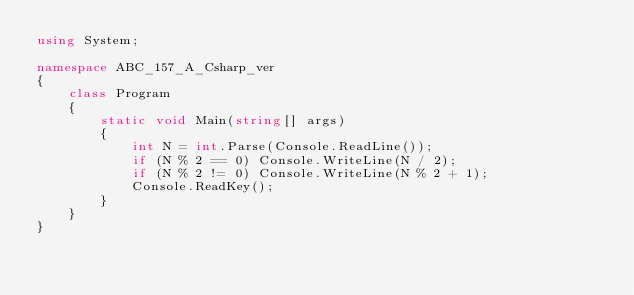Convert code to text. <code><loc_0><loc_0><loc_500><loc_500><_C#_>using System;

namespace ABC_157_A_Csharp_ver
{
    class Program
    {
        static void Main(string[] args)
        {
            int N = int.Parse(Console.ReadLine());
            if (N % 2 == 0) Console.WriteLine(N / 2);
            if (N % 2 != 0) Console.WriteLine(N % 2 + 1);
            Console.ReadKey();
        }
    }
}</code> 